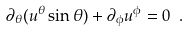Convert formula to latex. <formula><loc_0><loc_0><loc_500><loc_500>\partial _ { \theta } ( u ^ { \theta } \sin \theta ) + \partial _ { \phi } u ^ { \phi } = 0 \ .</formula> 